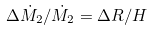Convert formula to latex. <formula><loc_0><loc_0><loc_500><loc_500>\Delta \dot { M } _ { 2 } / \dot { M } _ { 2 } = \Delta R / H</formula> 